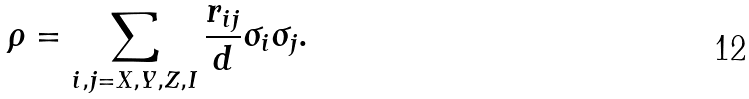Convert formula to latex. <formula><loc_0><loc_0><loc_500><loc_500>\rho = \sum _ { i , j = X , Y , Z , I } \frac { r _ { i j } } { d } \sigma _ { i } \sigma _ { j } .</formula> 